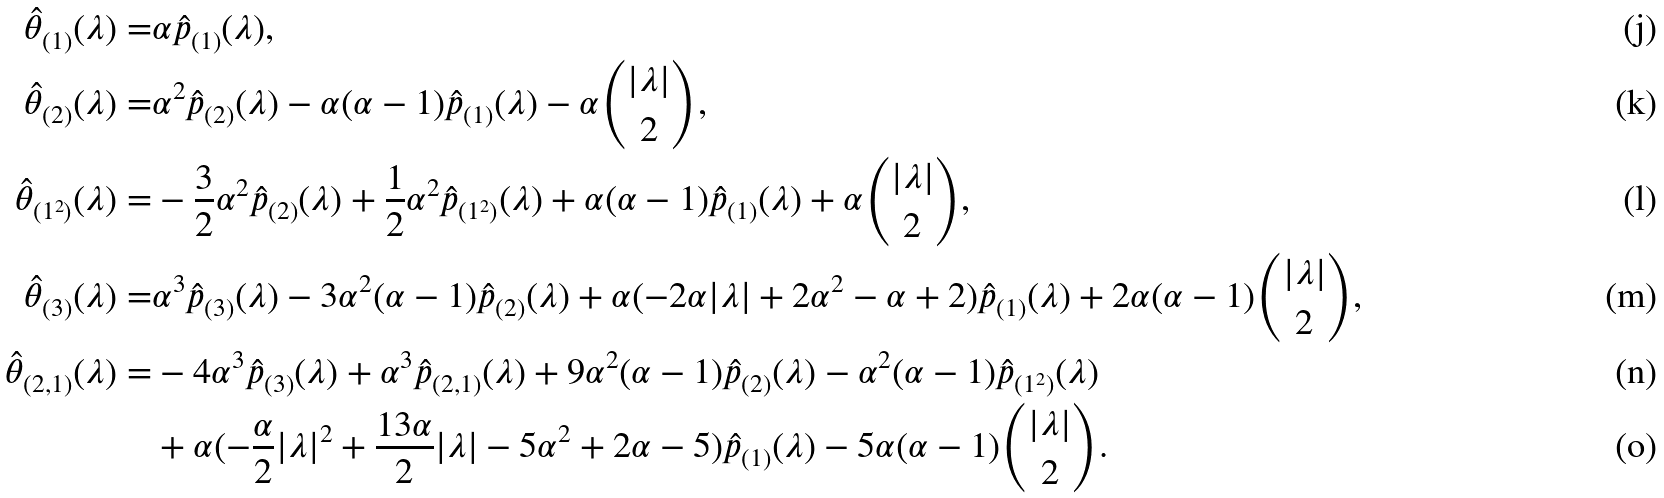<formula> <loc_0><loc_0><loc_500><loc_500>\hat { \theta } _ { ( 1 ) } ( \lambda ) = & \alpha \hat { p } _ { ( 1 ) } ( \lambda ) , \\ \hat { \theta } _ { ( 2 ) } ( \lambda ) = & \alpha ^ { 2 } \hat { p } _ { ( 2 ) } ( \lambda ) - \alpha ( \alpha - 1 ) \hat { p } _ { ( 1 ) } ( \lambda ) - \alpha \binom { | \lambda | } { 2 } , \\ \hat { \theta } _ { ( 1 ^ { 2 } ) } ( \lambda ) = & - \frac { 3 } { 2 } \alpha ^ { 2 } \hat { p } _ { ( 2 ) } ( \lambda ) + \frac { 1 } { 2 } \alpha ^ { 2 } \hat { p } _ { ( 1 ^ { 2 } ) } ( \lambda ) + \alpha ( \alpha - 1 ) \hat { p } _ { ( 1 ) } ( \lambda ) + \alpha \binom { | \lambda | } { 2 } , \\ \hat { \theta } _ { ( 3 ) } ( \lambda ) = & \alpha ^ { 3 } \hat { p } _ { ( 3 ) } ( \lambda ) - 3 \alpha ^ { 2 } ( \alpha - 1 ) \hat { p } _ { ( 2 ) } ( \lambda ) + \alpha ( - 2 \alpha | \lambda | + 2 \alpha ^ { 2 } - \alpha + 2 ) \hat { p } _ { ( 1 ) } ( \lambda ) + 2 \alpha ( \alpha - 1 ) \binom { | \lambda | } { 2 } , \\ \hat { \theta } _ { ( 2 , 1 ) } ( \lambda ) = & - 4 \alpha ^ { 3 } \hat { p } _ { ( 3 ) } ( \lambda ) + \alpha ^ { 3 } \hat { p } _ { ( 2 , 1 ) } ( \lambda ) + 9 \alpha ^ { 2 } ( \alpha - 1 ) \hat { p } _ { ( 2 ) } ( \lambda ) - \alpha ^ { 2 } ( \alpha - 1 ) \hat { p } _ { ( 1 ^ { 2 } ) } ( \lambda ) \\ & + \alpha ( - \frac { \alpha } { 2 } | \lambda | ^ { 2 } + \frac { 1 3 \alpha } { 2 } | \lambda | - 5 \alpha ^ { 2 } + 2 \alpha - 5 ) \hat { p } _ { ( 1 ) } ( \lambda ) - 5 \alpha ( \alpha - 1 ) \binom { | \lambda | } { 2 } .</formula> 